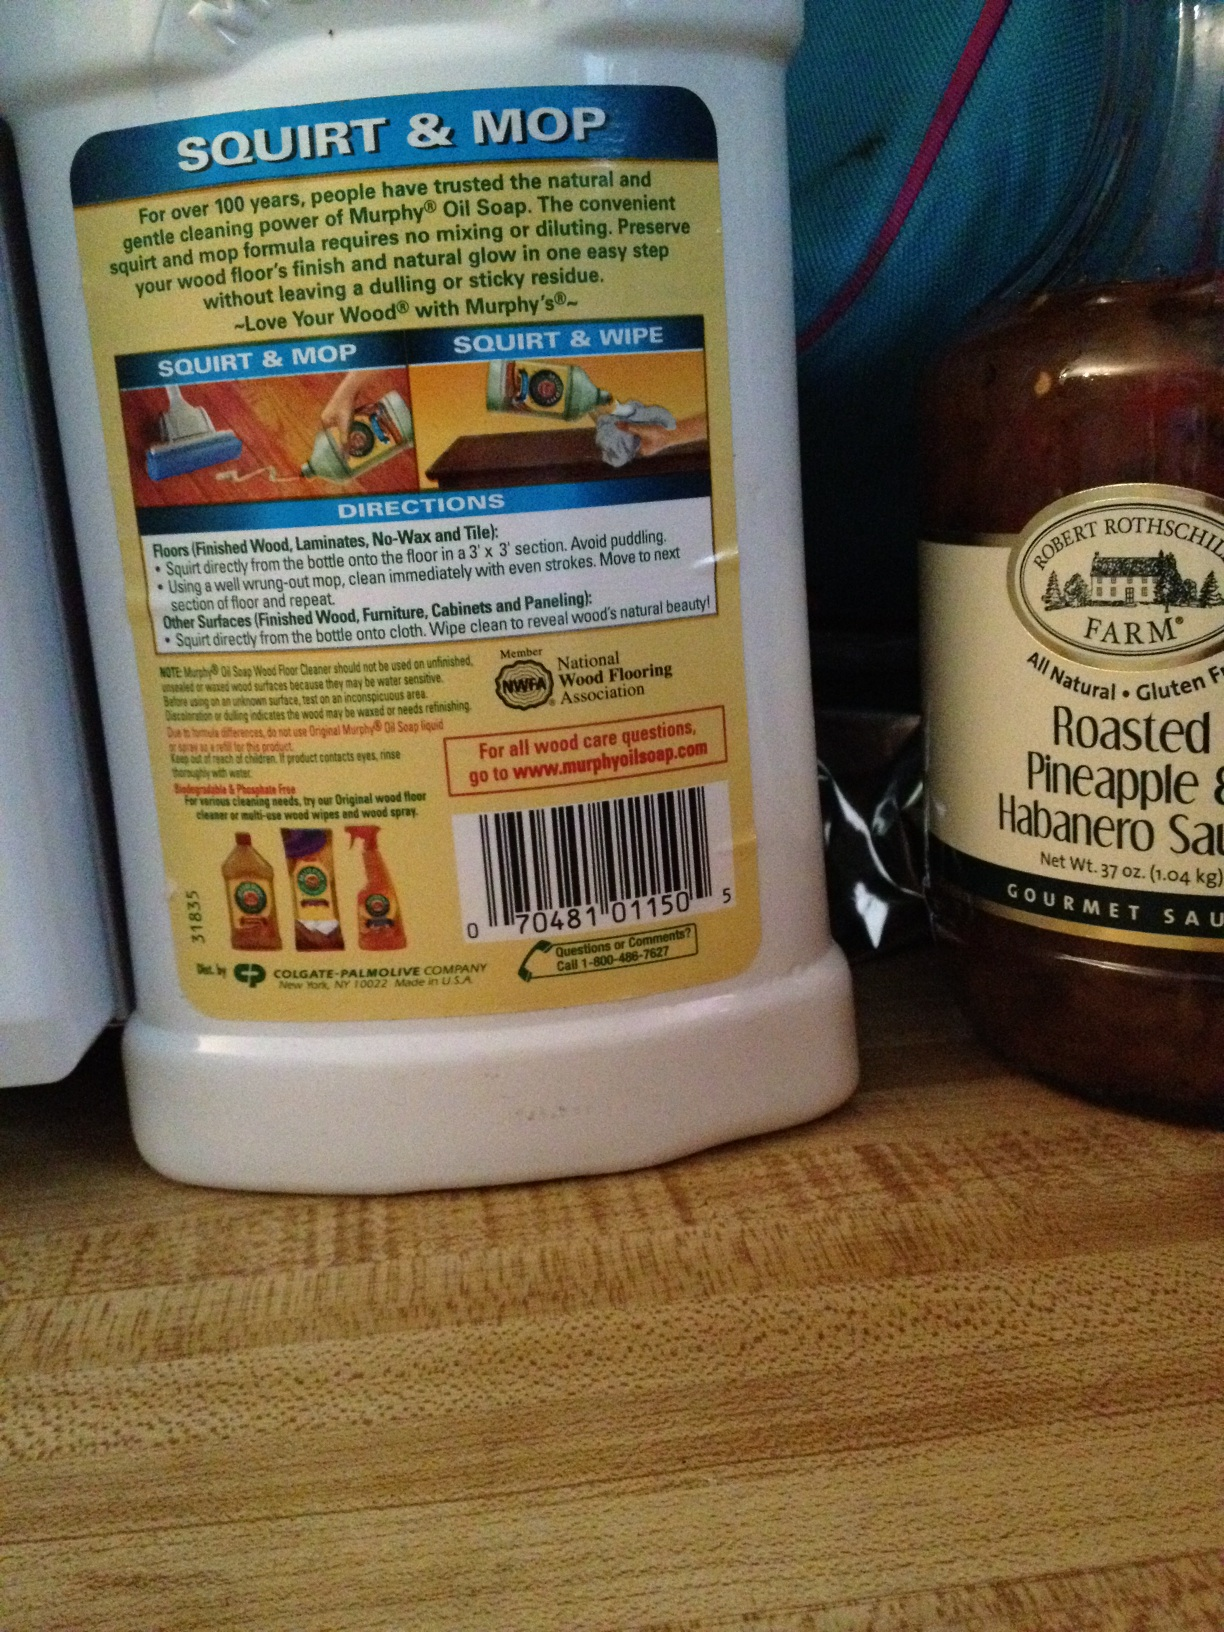Is there any specific surface that should not be cleaned with this product according to the label? The label does not explicitly mention any surfaces that should not be cleaned with Murphy’s Oil Soap, but it emphasizes use on finished wood, laminates, no-wax, and tile floors. It's advisable to always check the suitability on a small, inconspicuous area first if uncertainty exists for other surfaces. 